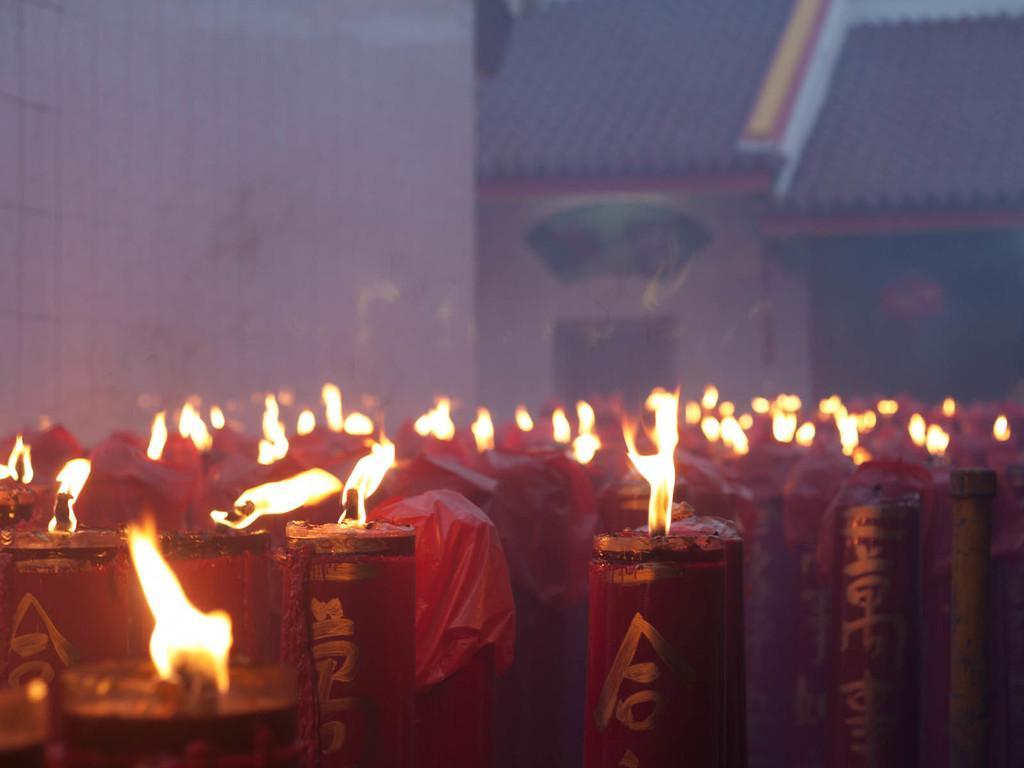Please provide a concise description of this image. In this image we can see a group of candles are light up with fire. In the background, we can see the building. 